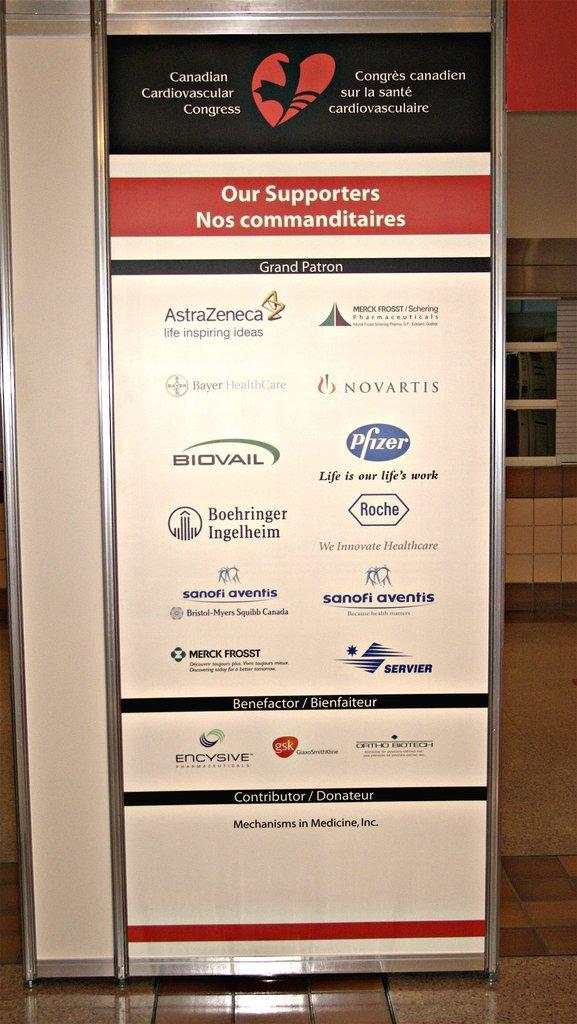How would you summarize this image in a sentence or two? We can see board on the floor. In the background we can see wall and glass. 